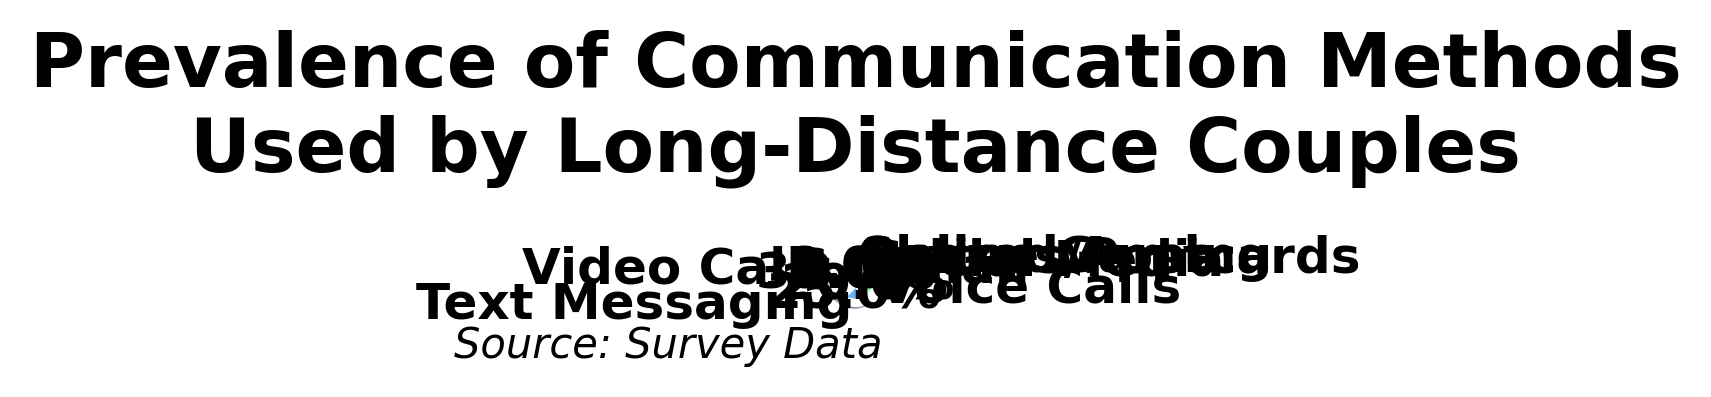What's the most commonly used communication method by long-distance couples? The figure shows different communication methods with their respective percentages. By inspecting the largest segment, which is Video Calls with 35%, we can determine the most common method.
Answer: Video Calls Which communication method is used less frequently: Letters/Postcards or Social Media? By comparing the percentages for Letters/Postcards (3%) and Social Media (6%), it's evident that Letters/Postcards are used less frequently.
Answer: Letters/Postcards What's the total percentage of couples using either Voice Calls or Text Messaging? Combine the percentages of Voice Calls (20%) and Text Messaging (25%). Adding 20% and 25% gives us 45%.
Answer: 45% Is the percentage of couples using Email higher than the percentage of those using Letters/Postcards? Compare the percentages for Email (8%) and Letters/Postcards (3%). Since 8% is greater than 3%, Email has a higher percentage.
Answer: Yes How many communication methods have a usage percentage of 10% or more? Examine each segment and its percentage: Video Calls (35%), Text Messaging (25%), and Voice Calls (20%) are the only methods above 10%. Therefore, there are 3 methods.
Answer: 3 Does the percentage for Online Gaming exceed that for Shared Apps? Compare the percentages for Online Gaming (1%) and Shared Apps (2%). Because 1% is less than 2%, Online Gaming does not exceed Shared Apps.
Answer: No Which communication method occupies a green section in the pie chart? By observing the colors and corresponding communication methods given in the data, Text Messaging appears to be associated with green color.
Answer: Text Messaging Is the segment for Video Calls larger than the combined segments of Social Media and Letters/Postcards? Evaluate the sizes: Video Calls have 35%, whereas Social Media has 6% and Letters/Postcards have 3%, totaling 9%. Since 35% > 9%, the Video Calls segment is larger.
Answer: Yes Calculate the difference in prevalence between the most common and the least common communication methods. The most common is Video Calls (35%) and the least common is Online Gaming (1%). The difference is 35% - 1% = 34%.
Answer: 34% Which has a larger segment: Voice Calls or Social Media? Compare the percentages: Voice Calls (20%) versus Social Media (6%). Since 20% is greater than 6%, Voice Calls has a larger segment.
Answer: Voice Calls 